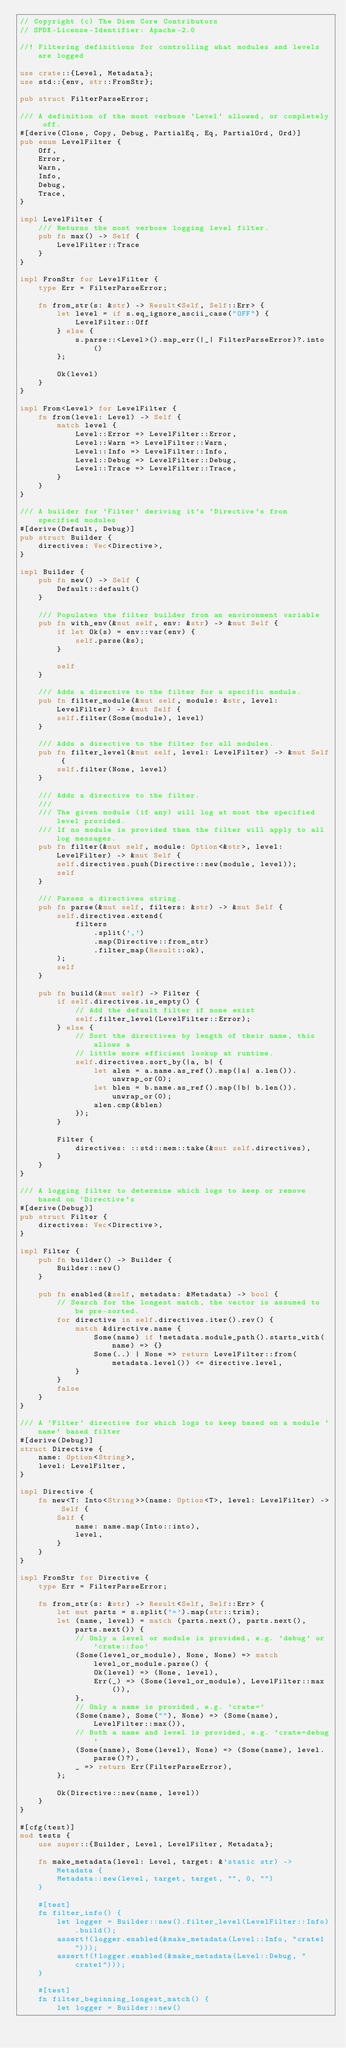<code> <loc_0><loc_0><loc_500><loc_500><_Rust_>// Copyright (c) The Diem Core Contributors
// SPDX-License-Identifier: Apache-2.0

//! Filtering definitions for controlling what modules and levels are logged

use crate::{Level, Metadata};
use std::{env, str::FromStr};

pub struct FilterParseError;

/// A definition of the most verbose `Level` allowed, or completely off.
#[derive(Clone, Copy, Debug, PartialEq, Eq, PartialOrd, Ord)]
pub enum LevelFilter {
    Off,
    Error,
    Warn,
    Info,
    Debug,
    Trace,
}

impl LevelFilter {
    /// Returns the most verbose logging level filter.
    pub fn max() -> Self {
        LevelFilter::Trace
    }
}

impl FromStr for LevelFilter {
    type Err = FilterParseError;

    fn from_str(s: &str) -> Result<Self, Self::Err> {
        let level = if s.eq_ignore_ascii_case("OFF") {
            LevelFilter::Off
        } else {
            s.parse::<Level>().map_err(|_| FilterParseError)?.into()
        };

        Ok(level)
    }
}

impl From<Level> for LevelFilter {
    fn from(level: Level) -> Self {
        match level {
            Level::Error => LevelFilter::Error,
            Level::Warn => LevelFilter::Warn,
            Level::Info => LevelFilter::Info,
            Level::Debug => LevelFilter::Debug,
            Level::Trace => LevelFilter::Trace,
        }
    }
}

/// A builder for `Filter` deriving it's `Directive`s from specified modules
#[derive(Default, Debug)]
pub struct Builder {
    directives: Vec<Directive>,
}

impl Builder {
    pub fn new() -> Self {
        Default::default()
    }

    /// Populates the filter builder from an environment variable
    pub fn with_env(&mut self, env: &str) -> &mut Self {
        if let Ok(s) = env::var(env) {
            self.parse(&s);
        }

        self
    }

    /// Adds a directive to the filter for a specific module.
    pub fn filter_module(&mut self, module: &str, level: LevelFilter) -> &mut Self {
        self.filter(Some(module), level)
    }

    /// Adds a directive to the filter for all modules.
    pub fn filter_level(&mut self, level: LevelFilter) -> &mut Self {
        self.filter(None, level)
    }

    /// Adds a directive to the filter.
    ///
    /// The given module (if any) will log at most the specified level provided.
    /// If no module is provided then the filter will apply to all log messages.
    pub fn filter(&mut self, module: Option<&str>, level: LevelFilter) -> &mut Self {
        self.directives.push(Directive::new(module, level));
        self
    }

    /// Parses a directives string.
    pub fn parse(&mut self, filters: &str) -> &mut Self {
        self.directives.extend(
            filters
                .split(',')
                .map(Directive::from_str)
                .filter_map(Result::ok),
        );
        self
    }

    pub fn build(&mut self) -> Filter {
        if self.directives.is_empty() {
            // Add the default filter if none exist
            self.filter_level(LevelFilter::Error);
        } else {
            // Sort the directives by length of their name, this allows a
            // little more efficient lookup at runtime.
            self.directives.sort_by(|a, b| {
                let alen = a.name.as_ref().map(|a| a.len()).unwrap_or(0);
                let blen = b.name.as_ref().map(|b| b.len()).unwrap_or(0);
                alen.cmp(&blen)
            });
        }

        Filter {
            directives: ::std::mem::take(&mut self.directives),
        }
    }
}

/// A logging filter to determine which logs to keep or remove based on `Directive`s
#[derive(Debug)]
pub struct Filter {
    directives: Vec<Directive>,
}

impl Filter {
    pub fn builder() -> Builder {
        Builder::new()
    }

    pub fn enabled(&self, metadata: &Metadata) -> bool {
        // Search for the longest match, the vector is assumed to be pre-sorted.
        for directive in self.directives.iter().rev() {
            match &directive.name {
                Some(name) if !metadata.module_path().starts_with(name) => {}
                Some(..) | None => return LevelFilter::from(metadata.level()) <= directive.level,
            }
        }
        false
    }
}

/// A `Filter` directive for which logs to keep based on a module `name` based filter
#[derive(Debug)]
struct Directive {
    name: Option<String>,
    level: LevelFilter,
}

impl Directive {
    fn new<T: Into<String>>(name: Option<T>, level: LevelFilter) -> Self {
        Self {
            name: name.map(Into::into),
            level,
        }
    }
}

impl FromStr for Directive {
    type Err = FilterParseError;

    fn from_str(s: &str) -> Result<Self, Self::Err> {
        let mut parts = s.split('=').map(str::trim);
        let (name, level) = match (parts.next(), parts.next(), parts.next()) {
            // Only a level or module is provided, e.g. 'debug' or 'crate::foo'
            (Some(level_or_module), None, None) => match level_or_module.parse() {
                Ok(level) => (None, level),
                Err(_) => (Some(level_or_module), LevelFilter::max()),
            },
            // Only a name is provided, e.g. 'crate='
            (Some(name), Some(""), None) => (Some(name), LevelFilter::max()),
            // Both a name and level is provided, e.g. 'crate=debug'
            (Some(name), Some(level), None) => (Some(name), level.parse()?),
            _ => return Err(FilterParseError),
        };

        Ok(Directive::new(name, level))
    }
}

#[cfg(test)]
mod tests {
    use super::{Builder, Level, LevelFilter, Metadata};

    fn make_metadata(level: Level, target: &'static str) -> Metadata {
        Metadata::new(level, target, target, "", 0, "")
    }

    #[test]
    fn filter_info() {
        let logger = Builder::new().filter_level(LevelFilter::Info).build();
        assert!(logger.enabled(&make_metadata(Level::Info, "crate1")));
        assert!(!logger.enabled(&make_metadata(Level::Debug, "crate1")));
    }

    #[test]
    fn filter_beginning_longest_match() {
        let logger = Builder::new()</code> 